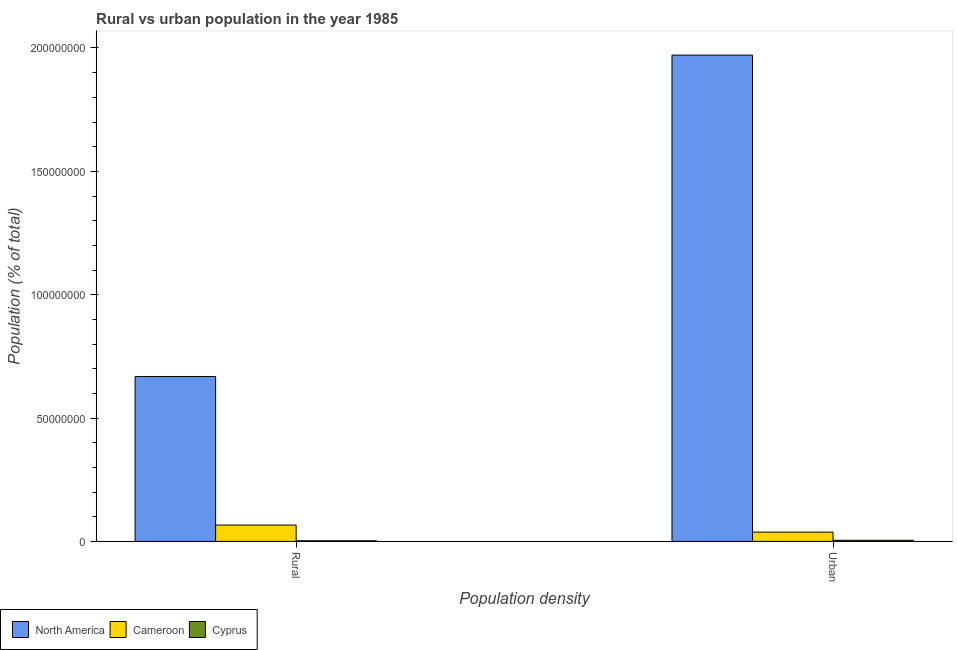How many different coloured bars are there?
Keep it short and to the point. 3. Are the number of bars on each tick of the X-axis equal?
Offer a very short reply. Yes. How many bars are there on the 2nd tick from the right?
Ensure brevity in your answer.  3. What is the label of the 2nd group of bars from the left?
Make the answer very short. Urban. What is the urban population density in Cyprus?
Ensure brevity in your answer.  4.55e+05. Across all countries, what is the maximum urban population density?
Give a very brief answer. 1.97e+08. Across all countries, what is the minimum rural population density?
Keep it short and to the point. 2.49e+05. In which country was the rural population density maximum?
Provide a succinct answer. North America. In which country was the urban population density minimum?
Make the answer very short. Cyprus. What is the total rural population density in the graph?
Your response must be concise. 7.37e+07. What is the difference between the urban population density in North America and that in Cameroon?
Make the answer very short. 1.93e+08. What is the difference between the rural population density in North America and the urban population density in Cyprus?
Make the answer very short. 6.64e+07. What is the average rural population density per country?
Provide a succinct answer. 2.46e+07. What is the difference between the rural population density and urban population density in North America?
Make the answer very short. -1.30e+08. What is the ratio of the rural population density in Cyprus to that in Cameroon?
Your answer should be compact. 0.04. Is the rural population density in Cyprus less than that in Cameroon?
Ensure brevity in your answer.  Yes. In how many countries, is the urban population density greater than the average urban population density taken over all countries?
Provide a succinct answer. 1. What does the 3rd bar from the left in Rural represents?
Provide a short and direct response. Cyprus. What does the 1st bar from the right in Urban represents?
Keep it short and to the point. Cyprus. How many bars are there?
Keep it short and to the point. 6. How many countries are there in the graph?
Your response must be concise. 3. Are the values on the major ticks of Y-axis written in scientific E-notation?
Your answer should be very brief. No. Does the graph contain grids?
Your answer should be very brief. No. Where does the legend appear in the graph?
Offer a very short reply. Bottom left. How many legend labels are there?
Your answer should be compact. 3. What is the title of the graph?
Your answer should be very brief. Rural vs urban population in the year 1985. What is the label or title of the X-axis?
Offer a terse response. Population density. What is the label or title of the Y-axis?
Give a very brief answer. Population (% of total). What is the Population (% of total) in North America in Rural?
Keep it short and to the point. 6.68e+07. What is the Population (% of total) of Cameroon in Rural?
Offer a very short reply. 6.62e+06. What is the Population (% of total) of Cyprus in Rural?
Your answer should be compact. 2.49e+05. What is the Population (% of total) in North America in Urban?
Give a very brief answer. 1.97e+08. What is the Population (% of total) in Cameroon in Urban?
Ensure brevity in your answer.  3.76e+06. What is the Population (% of total) of Cyprus in Urban?
Your response must be concise. 4.55e+05. Across all Population density, what is the maximum Population (% of total) in North America?
Offer a terse response. 1.97e+08. Across all Population density, what is the maximum Population (% of total) in Cameroon?
Offer a terse response. 6.62e+06. Across all Population density, what is the maximum Population (% of total) of Cyprus?
Keep it short and to the point. 4.55e+05. Across all Population density, what is the minimum Population (% of total) in North America?
Keep it short and to the point. 6.68e+07. Across all Population density, what is the minimum Population (% of total) in Cameroon?
Your response must be concise. 3.76e+06. Across all Population density, what is the minimum Population (% of total) of Cyprus?
Your answer should be compact. 2.49e+05. What is the total Population (% of total) of North America in the graph?
Ensure brevity in your answer.  2.64e+08. What is the total Population (% of total) of Cameroon in the graph?
Ensure brevity in your answer.  1.04e+07. What is the total Population (% of total) in Cyprus in the graph?
Provide a short and direct response. 7.04e+05. What is the difference between the Population (% of total) in North America in Rural and that in Urban?
Your answer should be compact. -1.30e+08. What is the difference between the Population (% of total) in Cameroon in Rural and that in Urban?
Make the answer very short. 2.86e+06. What is the difference between the Population (% of total) in Cyprus in Rural and that in Urban?
Make the answer very short. -2.07e+05. What is the difference between the Population (% of total) of North America in Rural and the Population (% of total) of Cameroon in Urban?
Make the answer very short. 6.31e+07. What is the difference between the Population (% of total) of North America in Rural and the Population (% of total) of Cyprus in Urban?
Ensure brevity in your answer.  6.64e+07. What is the difference between the Population (% of total) of Cameroon in Rural and the Population (% of total) of Cyprus in Urban?
Provide a succinct answer. 6.16e+06. What is the average Population (% of total) in North America per Population density?
Make the answer very short. 1.32e+08. What is the average Population (% of total) of Cameroon per Population density?
Keep it short and to the point. 5.19e+06. What is the average Population (% of total) in Cyprus per Population density?
Give a very brief answer. 3.52e+05. What is the difference between the Population (% of total) in North America and Population (% of total) in Cameroon in Rural?
Provide a short and direct response. 6.02e+07. What is the difference between the Population (% of total) in North America and Population (% of total) in Cyprus in Rural?
Your answer should be compact. 6.66e+07. What is the difference between the Population (% of total) in Cameroon and Population (% of total) in Cyprus in Rural?
Your answer should be compact. 6.37e+06. What is the difference between the Population (% of total) in North America and Population (% of total) in Cameroon in Urban?
Keep it short and to the point. 1.93e+08. What is the difference between the Population (% of total) in North America and Population (% of total) in Cyprus in Urban?
Provide a short and direct response. 1.97e+08. What is the difference between the Population (% of total) of Cameroon and Population (% of total) of Cyprus in Urban?
Offer a terse response. 3.31e+06. What is the ratio of the Population (% of total) of North America in Rural to that in Urban?
Your response must be concise. 0.34. What is the ratio of the Population (% of total) of Cameroon in Rural to that in Urban?
Your response must be concise. 1.76. What is the ratio of the Population (% of total) of Cyprus in Rural to that in Urban?
Offer a terse response. 0.55. What is the difference between the highest and the second highest Population (% of total) in North America?
Keep it short and to the point. 1.30e+08. What is the difference between the highest and the second highest Population (% of total) of Cameroon?
Your answer should be compact. 2.86e+06. What is the difference between the highest and the second highest Population (% of total) in Cyprus?
Offer a terse response. 2.07e+05. What is the difference between the highest and the lowest Population (% of total) of North America?
Provide a short and direct response. 1.30e+08. What is the difference between the highest and the lowest Population (% of total) in Cameroon?
Provide a short and direct response. 2.86e+06. What is the difference between the highest and the lowest Population (% of total) of Cyprus?
Your response must be concise. 2.07e+05. 